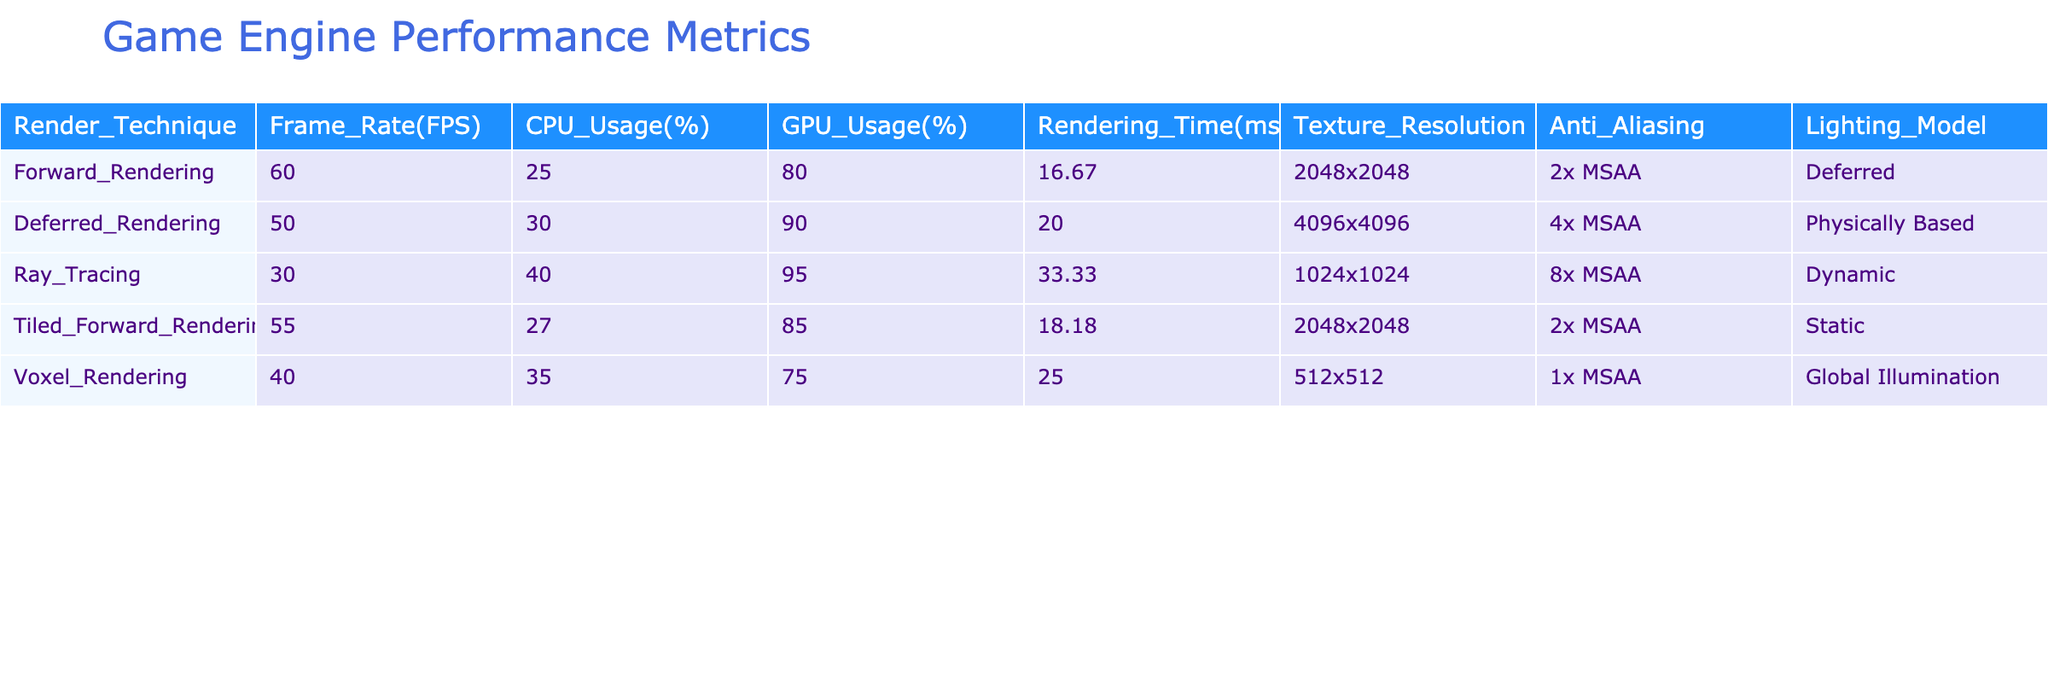What is the frame rate of Ray Tracing? The frame rate for Ray Tracing is listed as 30 FPS in the table.
Answer: 30 FPS Which rendering technique has the highest GPU usage? By comparing the GPU usage percentages in the table, Ray Tracing has the highest value at 95%.
Answer: 95% How much longer is the rendering time for Deferred Rendering compared to Forward Rendering? The rendering time for Deferred Rendering is 20.00 ms, while Forward Rendering is 16.67 ms. The difference is 20.00 - 16.67 = 3.33 ms.
Answer: 3.33 ms Is the texture resolution for Tiled Forward Rendering higher than that of Voxel Rendering? Tiled Forward Rendering has a texture resolution of 2048x2048 and Voxel Rendering has 512x512. Since 2048 is greater than 512, the answer is yes.
Answer: Yes What is the average CPU usage across all rendering techniques? To find the average CPU usage, sum the values: (25 + 30 + 40 + 27 + 35) = 157. Then divide by the number of techniques: 157 / 5 = 31.4.
Answer: 31.4 How many rendering techniques use MSAA of 2x? By examining the table, Forward Rendering and Tiled Forward Rendering both utilize 2x MSAA, making a total of 2 techniques.
Answer: 2 Which rendering technique has the lowest frame rate? Upon reviewing the frame rates in the table, Ray Tracing has the lowest frame rate at 30 FPS.
Answer: 30 FPS Is the anti-aliasing method used in Deferred Rendering more advanced than that used in Voxel Rendering? The Deferred Rendering technique uses 4x MSAA while Voxel Rendering uses 1x MSAA. Since 4x is a higher sample rate than 1x, it is indeed more advanced.
Answer: Yes What is the rendering time difference between the most efficient and least efficient rendering techniques? The most efficient technique is Forward Rendering with 16.67 ms and the least efficient is Ray Tracing with 33.33 ms. The difference is 33.33 - 16.67 = 16.66 ms.
Answer: 16.66 ms 